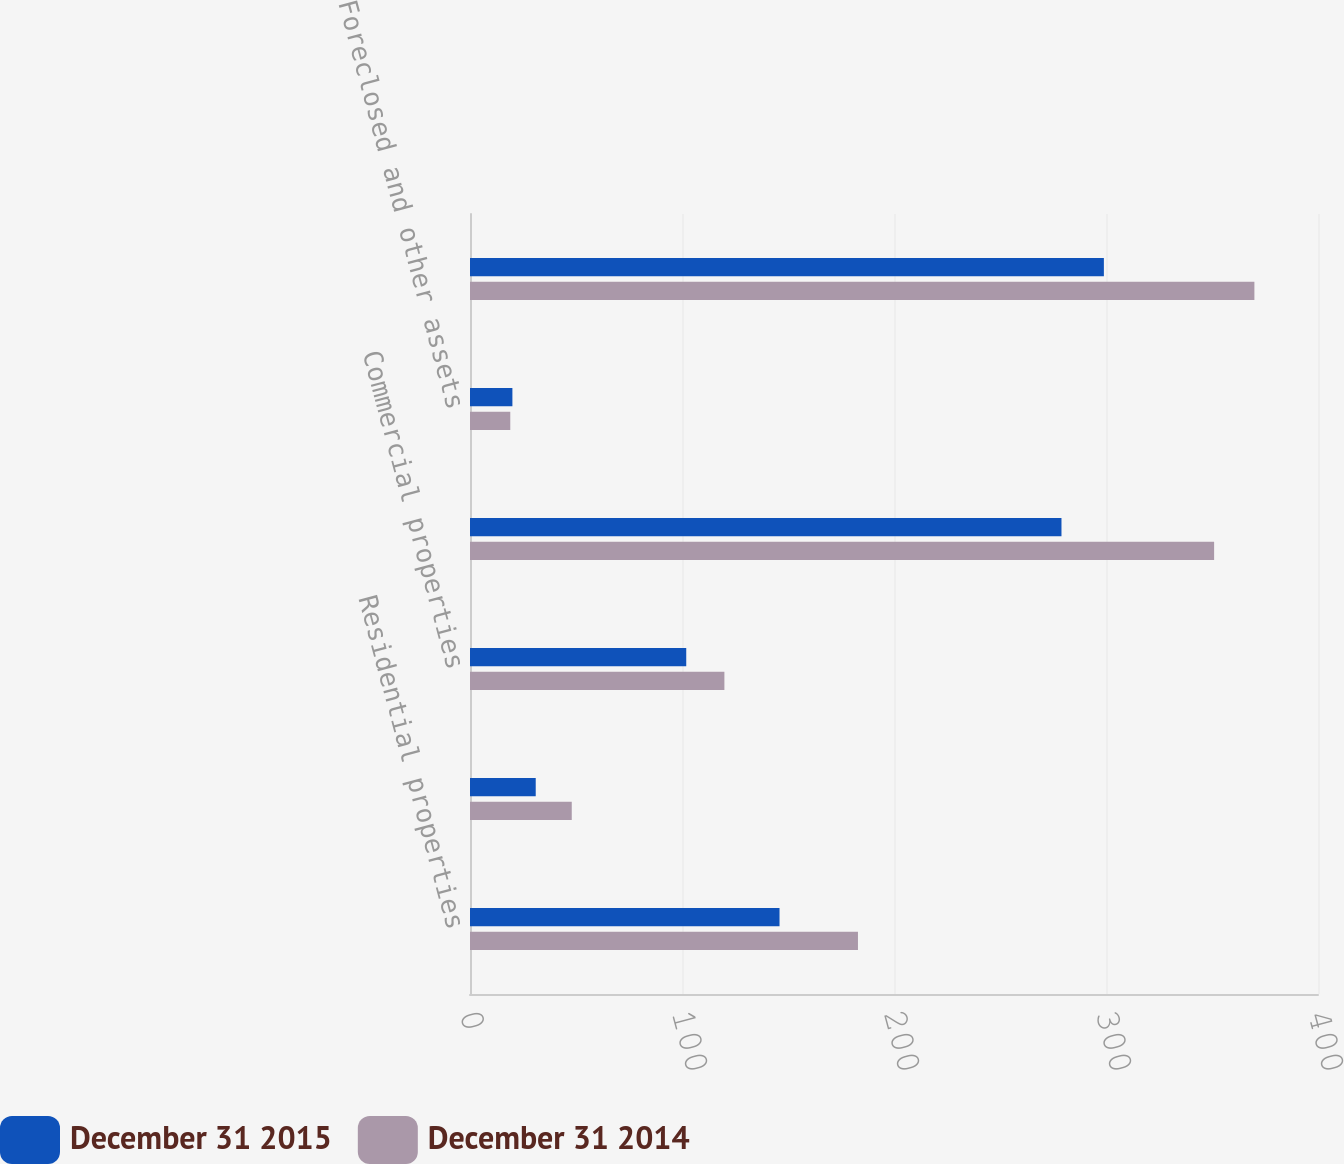Convert chart to OTSL. <chart><loc_0><loc_0><loc_500><loc_500><stacked_bar_chart><ecel><fcel>Residential properties<fcel>Residential development<fcel>Commercial properties<fcel>Total OREO<fcel>Foreclosed and other assets<fcel>Total OREO and foreclosed<nl><fcel>December 31 2015<fcel>146<fcel>31<fcel>102<fcel>279<fcel>20<fcel>299<nl><fcel>December 31 2014<fcel>183<fcel>48<fcel>120<fcel>351<fcel>19<fcel>370<nl></chart> 